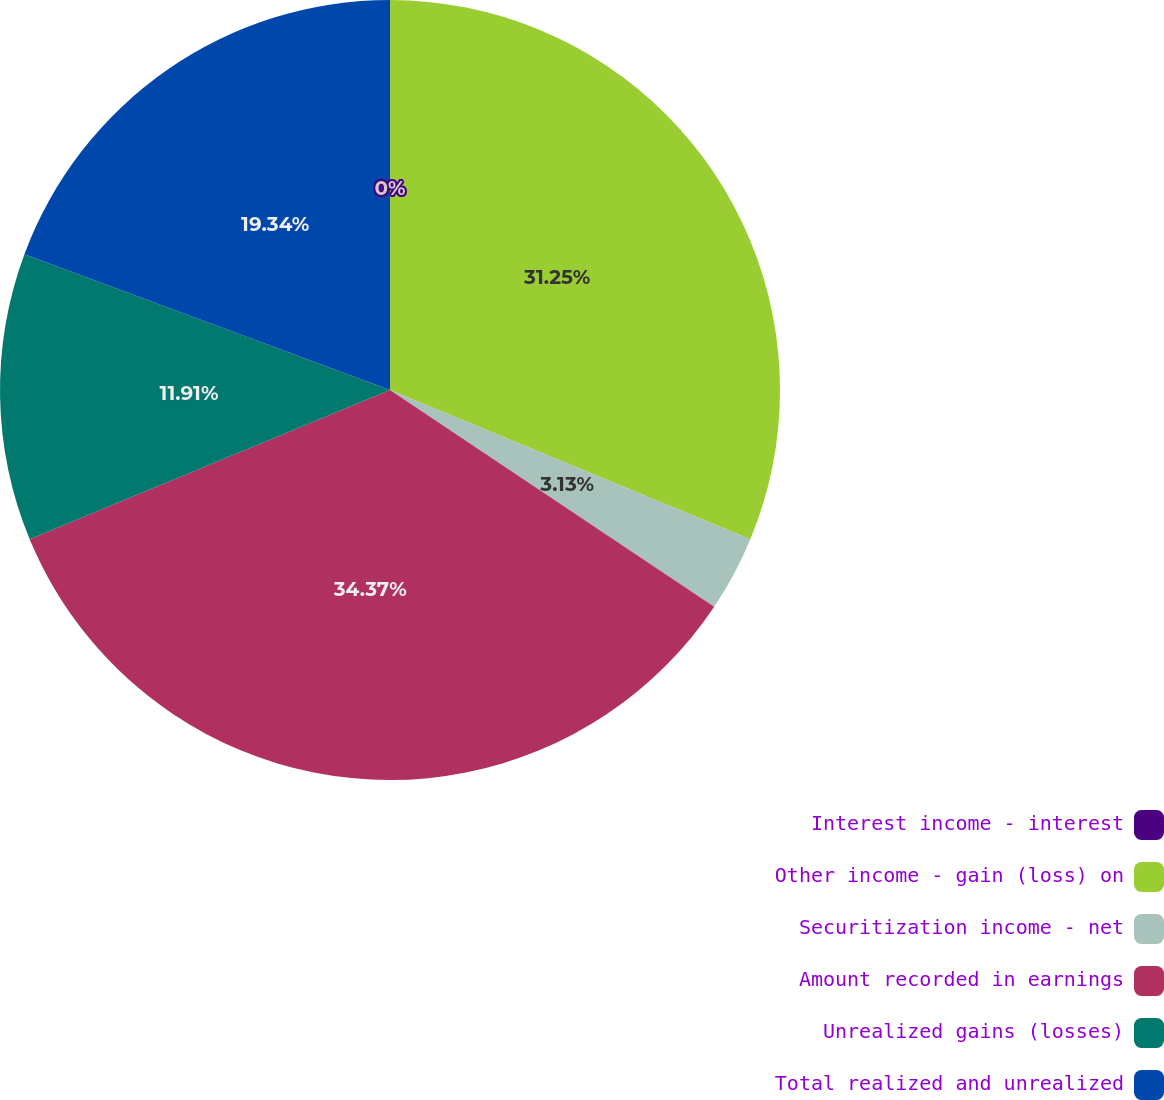Convert chart. <chart><loc_0><loc_0><loc_500><loc_500><pie_chart><fcel>Interest income - interest<fcel>Other income - gain (loss) on<fcel>Securitization income - net<fcel>Amount recorded in earnings<fcel>Unrealized gains (losses)<fcel>Total realized and unrealized<nl><fcel>0.0%<fcel>31.25%<fcel>3.13%<fcel>34.37%<fcel>11.91%<fcel>19.34%<nl></chart> 